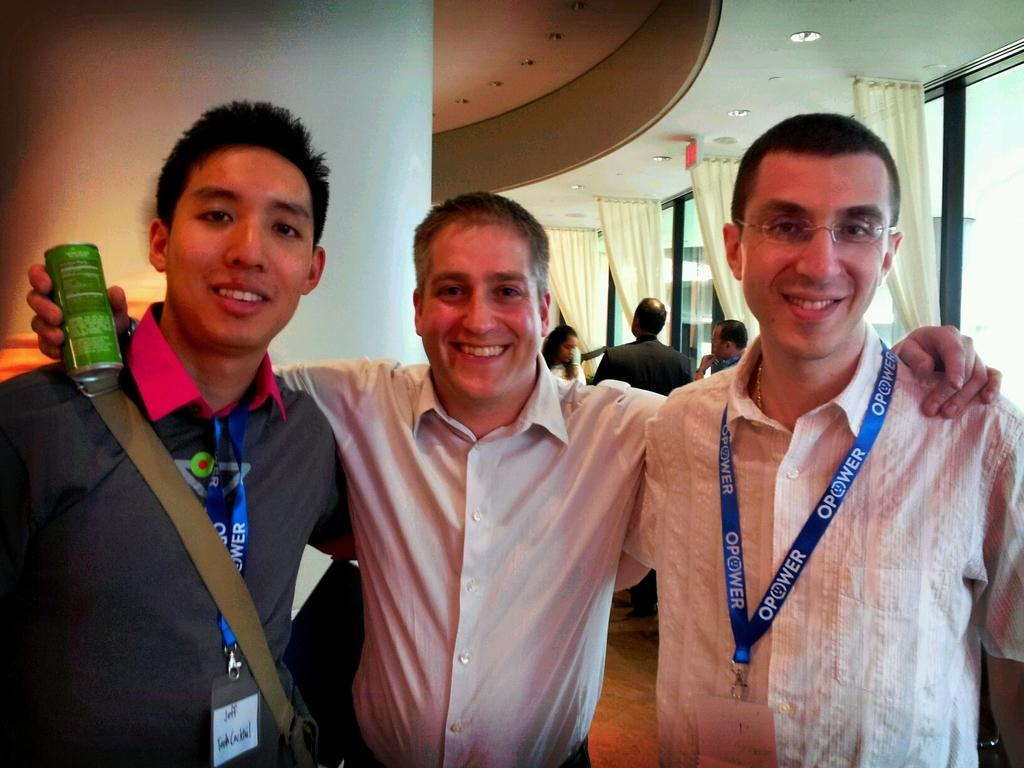<image>
Create a compact narrative representing the image presented. The male on the right is wearing a lanyard with the word opower. 